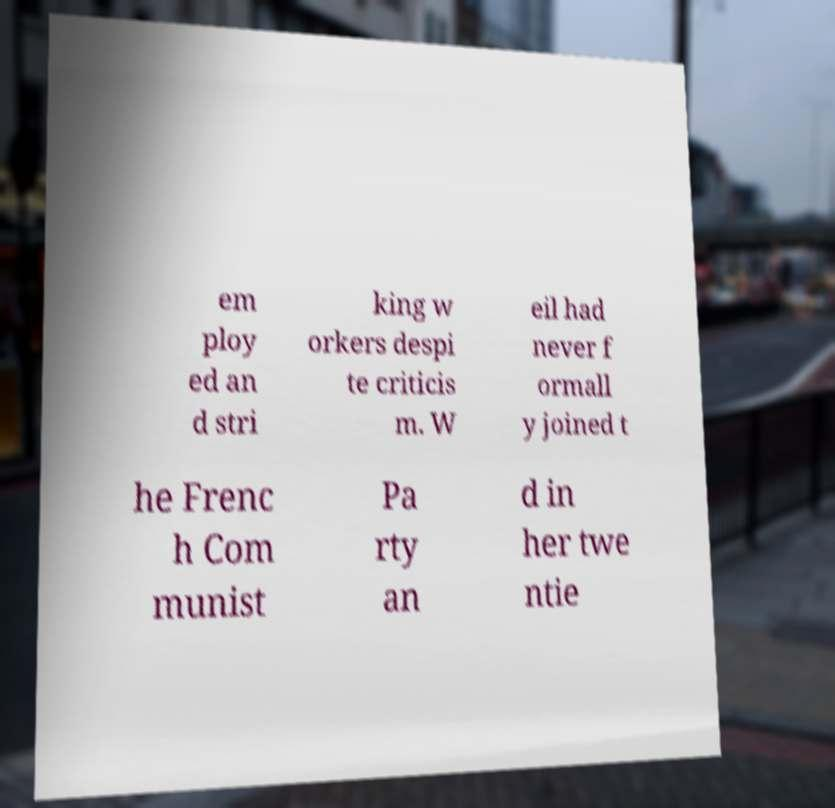Please read and relay the text visible in this image. What does it say? em ploy ed an d stri king w orkers despi te criticis m. W eil had never f ormall y joined t he Frenc h Com munist Pa rty an d in her twe ntie 